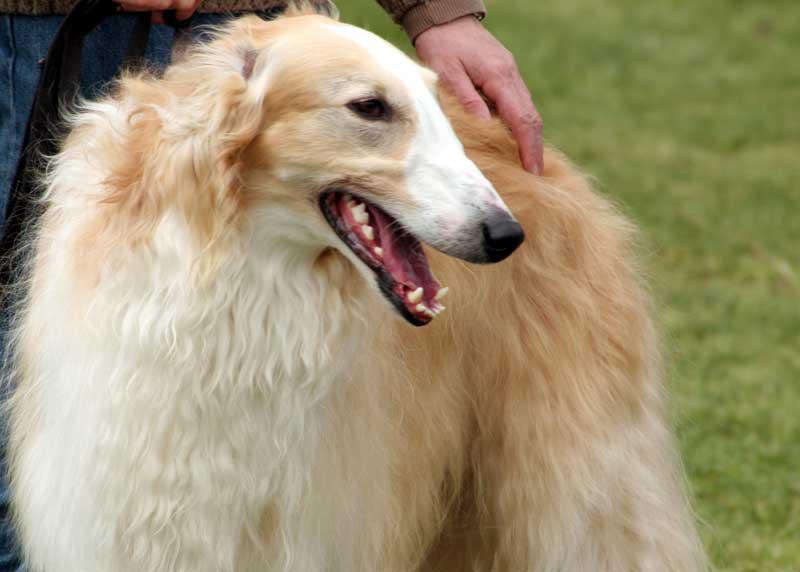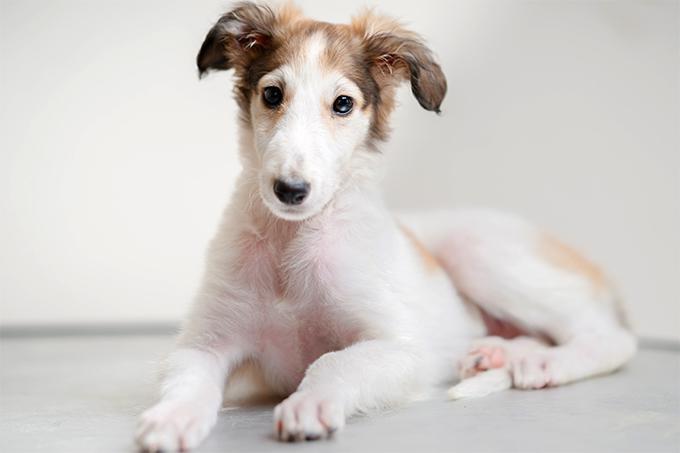The first image is the image on the left, the second image is the image on the right. Assess this claim about the two images: "Both of the dogs are in similar body positions and with similar backgrounds.". Correct or not? Answer yes or no. No. The first image is the image on the left, the second image is the image on the right. Examine the images to the left and right. Is the description "The dog in the image on the left is lying down." accurate? Answer yes or no. No. 